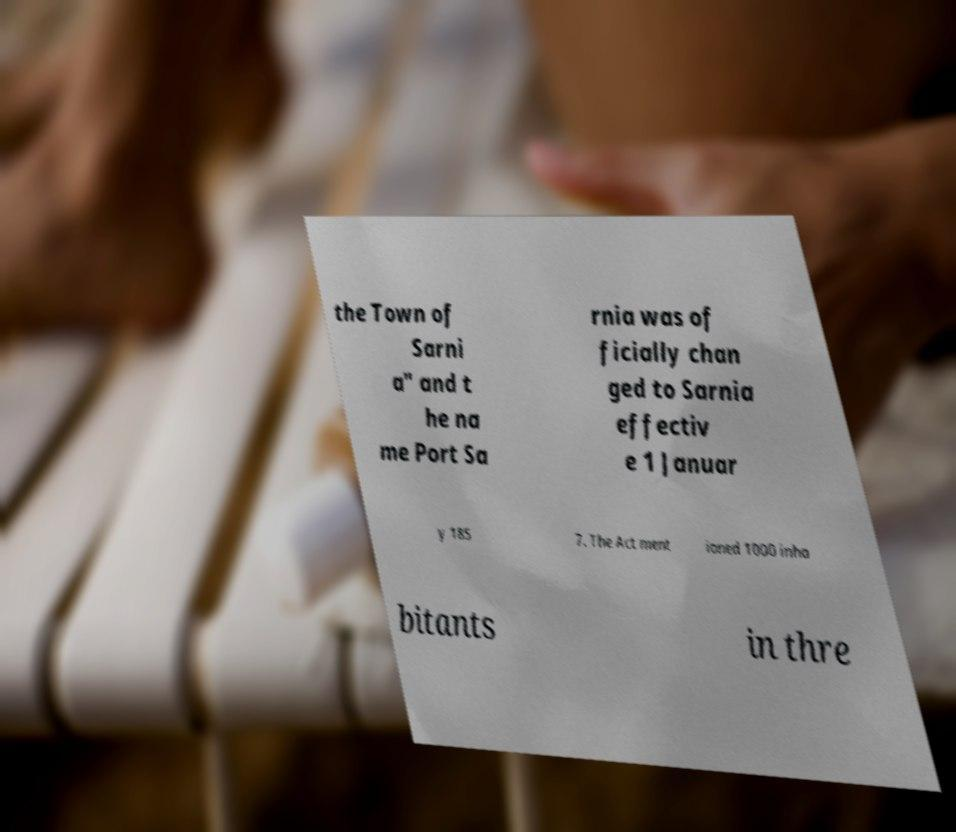For documentation purposes, I need the text within this image transcribed. Could you provide that? the Town of Sarni a" and t he na me Port Sa rnia was of ficially chan ged to Sarnia effectiv e 1 Januar y 185 7. The Act ment ioned 1000 inha bitants in thre 